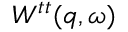<formula> <loc_0><loc_0><loc_500><loc_500>W ^ { t t } ( q , \omega )</formula> 